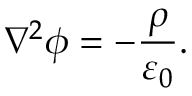<formula> <loc_0><loc_0><loc_500><loc_500>{ \nabla } ^ { 2 } \phi = - { \frac { \rho } { \varepsilon _ { 0 } } } .</formula> 